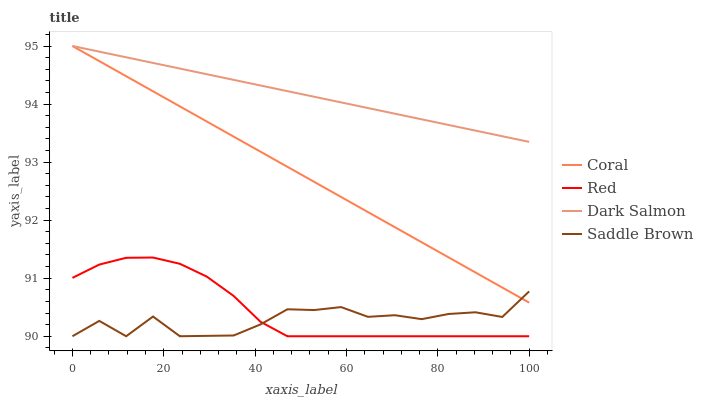Does Saddle Brown have the minimum area under the curve?
Answer yes or no. Yes. Does Dark Salmon have the maximum area under the curve?
Answer yes or no. Yes. Does Red have the minimum area under the curve?
Answer yes or no. No. Does Red have the maximum area under the curve?
Answer yes or no. No. Is Coral the smoothest?
Answer yes or no. Yes. Is Saddle Brown the roughest?
Answer yes or no. Yes. Is Dark Salmon the smoothest?
Answer yes or no. No. Is Dark Salmon the roughest?
Answer yes or no. No. Does Red have the lowest value?
Answer yes or no. Yes. Does Dark Salmon have the lowest value?
Answer yes or no. No. Does Dark Salmon have the highest value?
Answer yes or no. Yes. Does Red have the highest value?
Answer yes or no. No. Is Red less than Dark Salmon?
Answer yes or no. Yes. Is Dark Salmon greater than Saddle Brown?
Answer yes or no. Yes. Does Coral intersect Saddle Brown?
Answer yes or no. Yes. Is Coral less than Saddle Brown?
Answer yes or no. No. Is Coral greater than Saddle Brown?
Answer yes or no. No. Does Red intersect Dark Salmon?
Answer yes or no. No. 